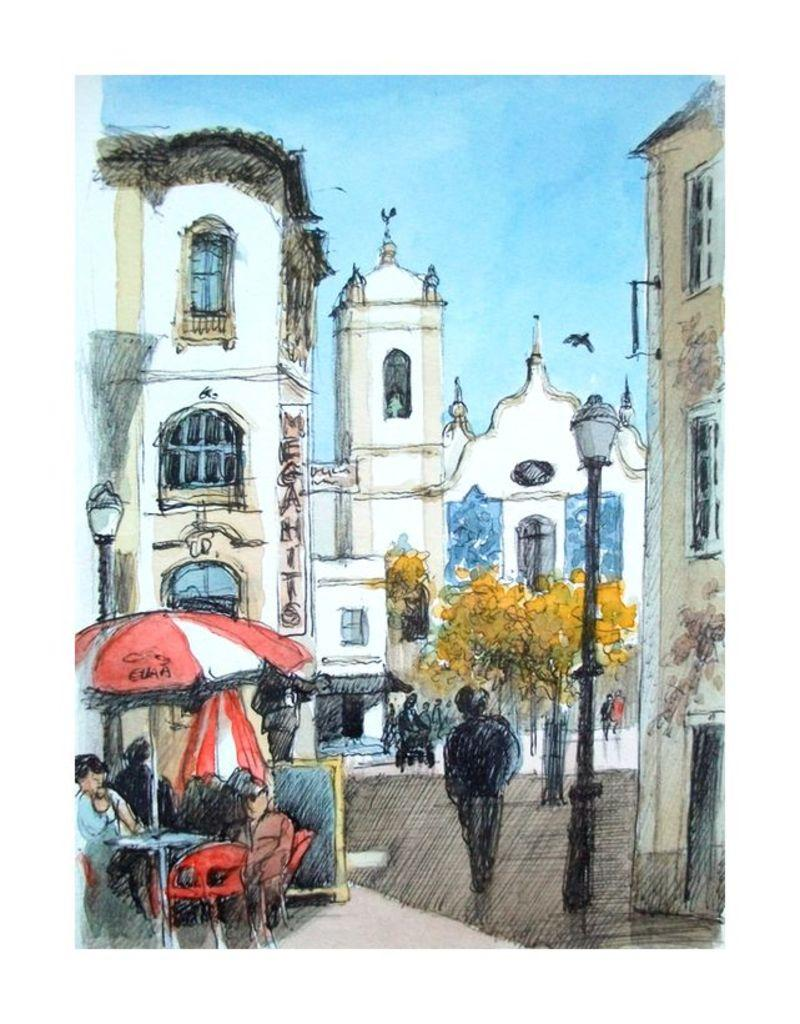What type of artwork is depicted in the image? The image appears to be a painting. What type of furniture is present in the painting? There is a table and chairs in the painting. Are there any people in the painting? Yes, there are people in the painting. What additional objects can be seen in the painting? There is an umbrella, a pole with a light, trees, buildings, and a bird in the painting. What part of the natural environment is visible in the painting? The sky is visible in the painting. What type of territory is being claimed by the bells in the painting? There are no bells present in the painting, so it is not possible to determine any territory being claimed. --- Facts: 1. There is a car in the image. 2. The car is red. 3. The car has four wheels. 4. There are people in the car. 5. The car has a roof. 6. The car has windows. Absurd Topics: parrot, volcano, ocean Conversation: What type of vehicle is in the image? There is a car in the image. What color is the car? The car is red. How many wheels does the car have? The car has four wheels. Are there any passengers in the car? Yes, there are people in the car. What features does the car have? The car has a roof and windows. Reasoning: Let's think step by step in order to produce the conversation. We start by identifying the main subject in the image, which is the car. Then, we describe the car's color, number of wheels, and the presence of passengers. Finally, we mention the car's features, including the roof and windows. Absurd Question/Answer: Can you see the parrot flying over the volcano near the ocean in the image? There is no parrot, volcano, or ocean present in the image; it features a red car with people inside. 